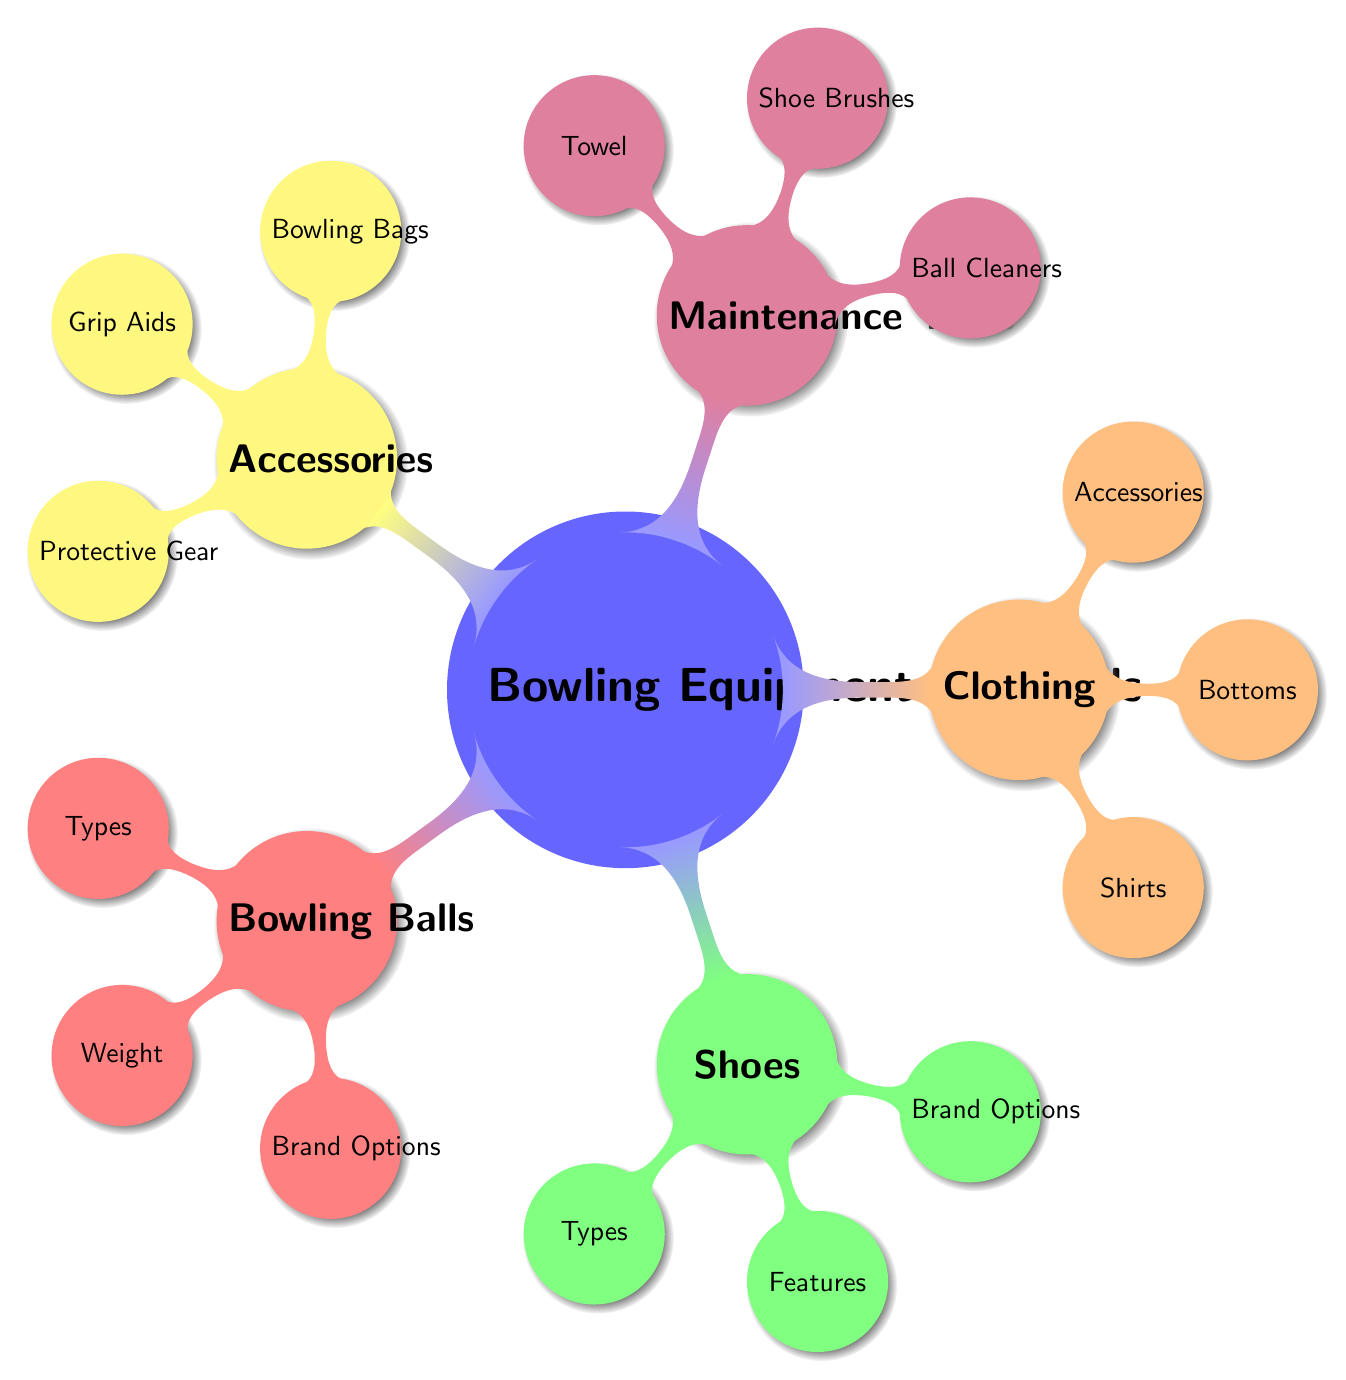What are the types of bowling balls? The diagram lists three specific types under the 'Bowling Balls' category: 'Plastic', 'Urethane', and 'Reactive Resin'.
Answer: Plastic, Urethane, Reactive Resin How many types of shoes are mentioned? There are two types of shoes listed under the 'Shoes' category: 'Performance Shoes' and 'Rental Shoes'. So, the total is two.
Answer: 2 Which brand options are available for bowling balls? The 'Bowling Balls' category provides three brand options: 'Brunswick', 'Storm', and 'Ebonite', representing the choices available for bowling balls.
Answer: Brunswick, Storm, Ebonite What is included under the clothing accessories? Under the 'Clothing' category, 'Accessories' includes 'Wrist Supports' and 'Socks' as part of the list.
Answer: Wrist Supports, Socks Which maintenance tool is listed for cleaning balls? The diagram indicates that 'Ball Cleaners' are included among the maintenance tools, and specifically mentions 'Alcohol-Based Cleaner' and 'Gel Cleaner' as options.
Answer: Alcohol-Based Cleaner, Gel Cleaner What kind of shoes have slide soles? The 'Shoes' node specifies that 'Performance Shoes' feature various types, including 'Slide Soles'. Hence, the answer is Performance Shoes.
Answer: Performance Shoes Which category includes "Double Ball Bag"? The 'Accessories' category lists different items, including 'Bowling Bags', one of which specifically is a 'Double Ball Bag', indicating it belongs to that category.
Answer: Accessories How many main categories of bowling equipment essentials are there? The primary 'Bowling Equipment Essentials' category has five main branches: 'Bowling Balls', 'Shoes', 'Clothing', 'Maintenance Tools', and 'Accessories', totaling five categories.
Answer: 5 Which maintenance tool uses a bristle brush? Under the 'Maintenance Tools' category, 'Shoe Brushes' include 'Bristle Brush' as one of the tools mentioned, indicating its usage in maintaining shoes.
Answer: Bristle Brush 